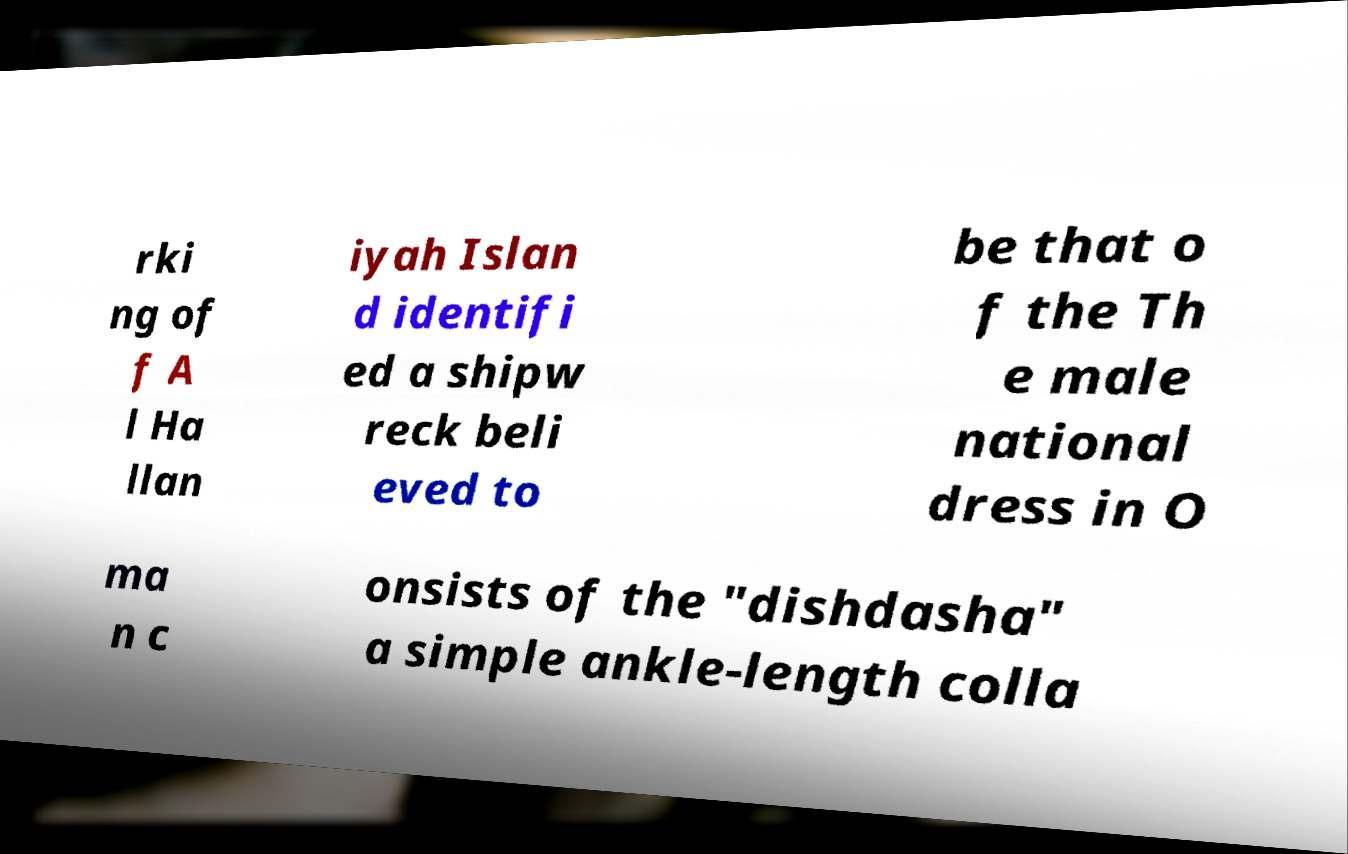Could you extract and type out the text from this image? rki ng of f A l Ha llan iyah Islan d identifi ed a shipw reck beli eved to be that o f the Th e male national dress in O ma n c onsists of the "dishdasha" a simple ankle-length colla 